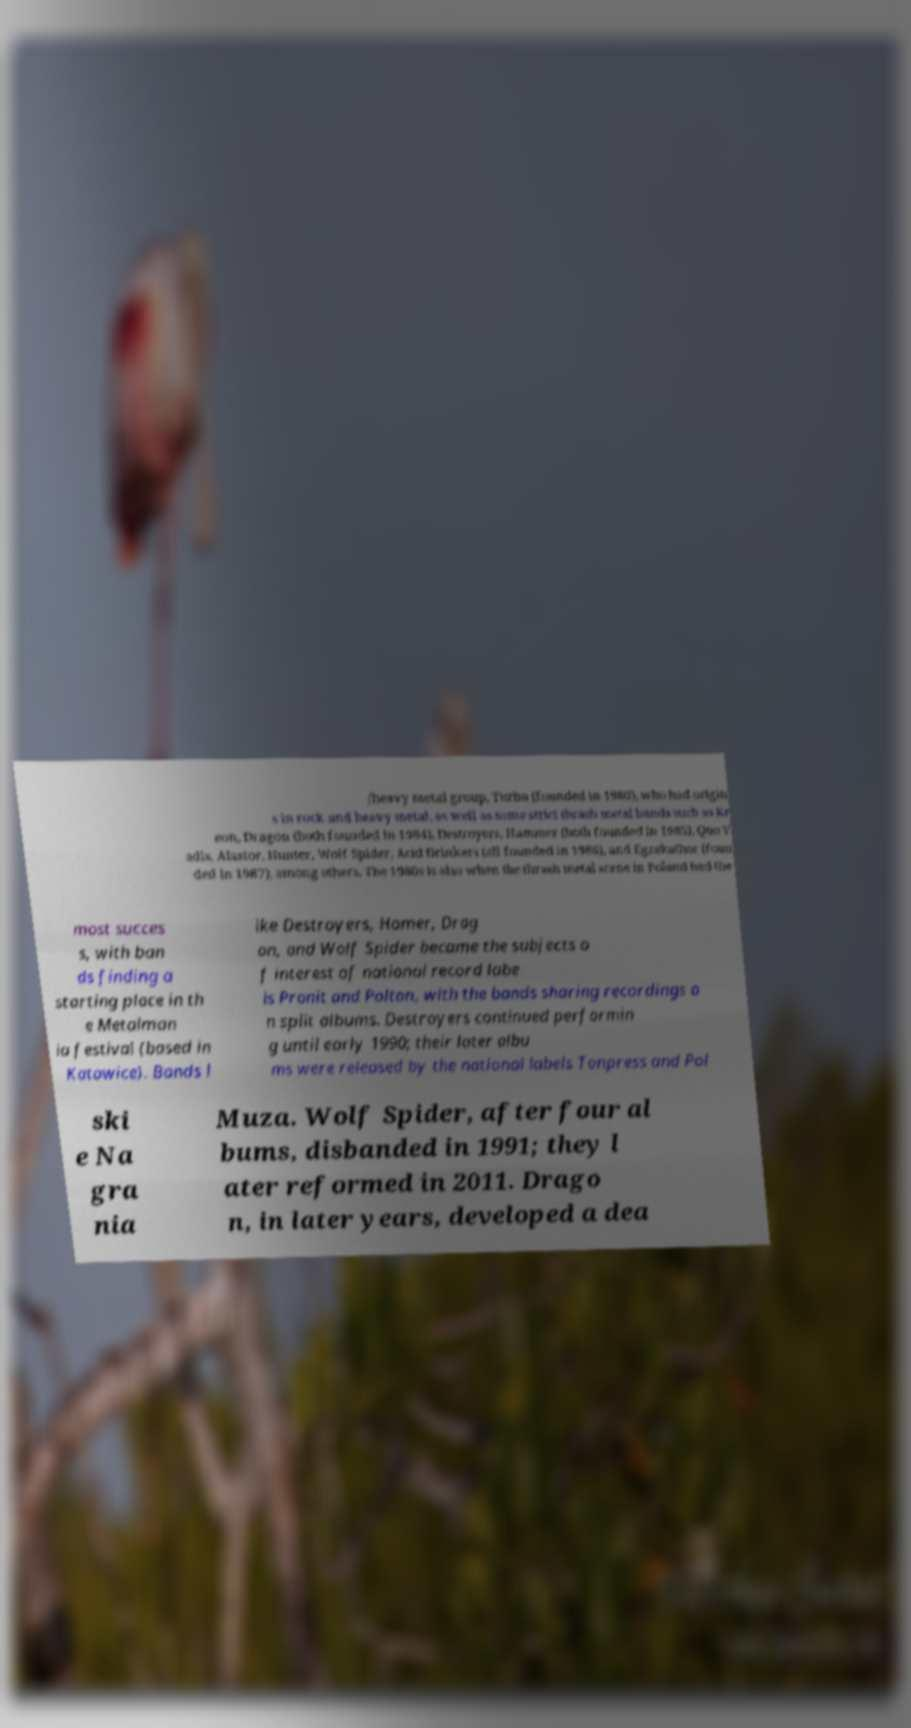What messages or text are displayed in this image? I need them in a readable, typed format. /heavy metal group, Turbo (founded in 1980), who had origin s in rock and heavy metal, as well as some strict thrash metal bands such as Kr eon, Dragon (both founded in 1984), Destroyers, Hammer (both founded in 1985), Quo V adis, Alastor, Hunter, Wolf Spider, Acid Drinkers (all founded in 1986), and Egzekuthor (foun ded in 1987), among others. The 1980s is also when the thrash metal scene in Poland had the most succes s, with ban ds finding a starting place in th e Metalman ia festival (based in Katowice). Bands l ike Destroyers, Hamer, Drag on, and Wolf Spider became the subjects o f interest of national record labe ls Pronit and Polton, with the bands sharing recordings o n split albums. Destroyers continued performin g until early 1990; their later albu ms were released by the national labels Tonpress and Pol ski e Na gra nia Muza. Wolf Spider, after four al bums, disbanded in 1991; they l ater reformed in 2011. Drago n, in later years, developed a dea 